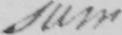What is written in this line of handwriting? sum 